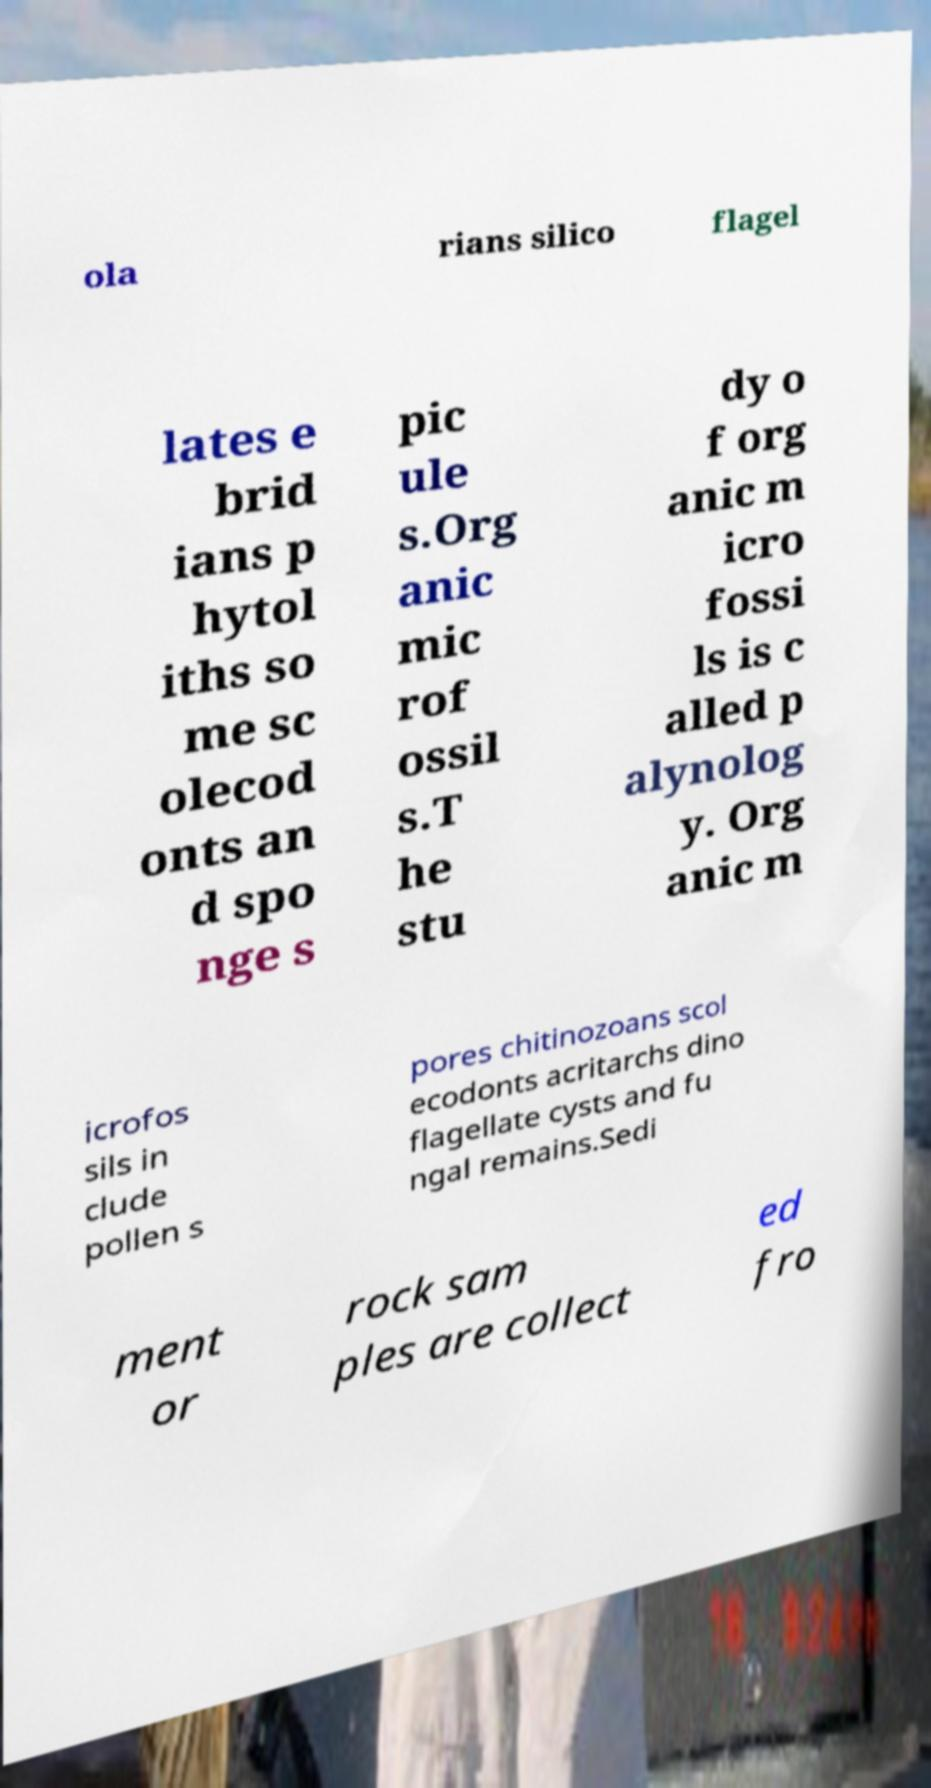Please identify and transcribe the text found in this image. ola rians silico flagel lates e brid ians p hytol iths so me sc olecod onts an d spo nge s pic ule s.Org anic mic rof ossil s.T he stu dy o f org anic m icro fossi ls is c alled p alynolog y. Org anic m icrofos sils in clude pollen s pores chitinozoans scol ecodonts acritarchs dino flagellate cysts and fu ngal remains.Sedi ment or rock sam ples are collect ed fro 